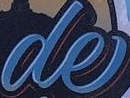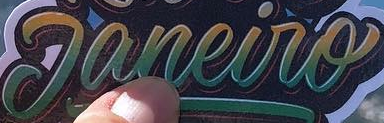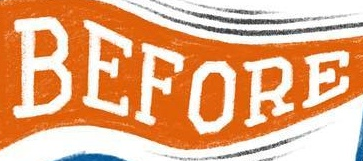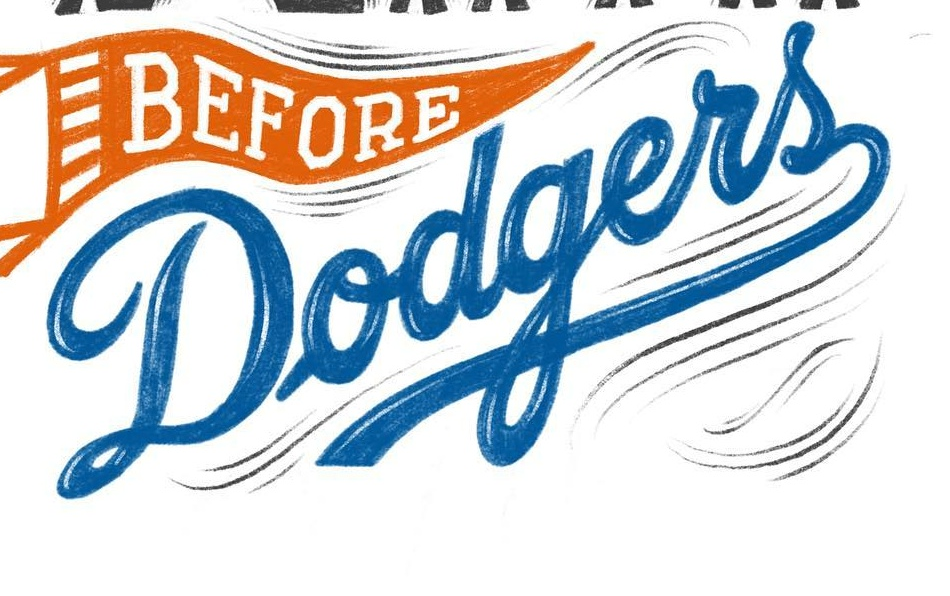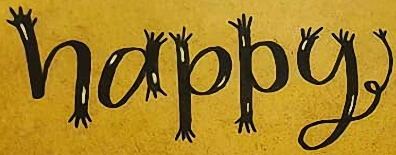Read the text content from these images in order, separated by a semicolon. de; Janeiro; BEFORE; Dodgers; happy 